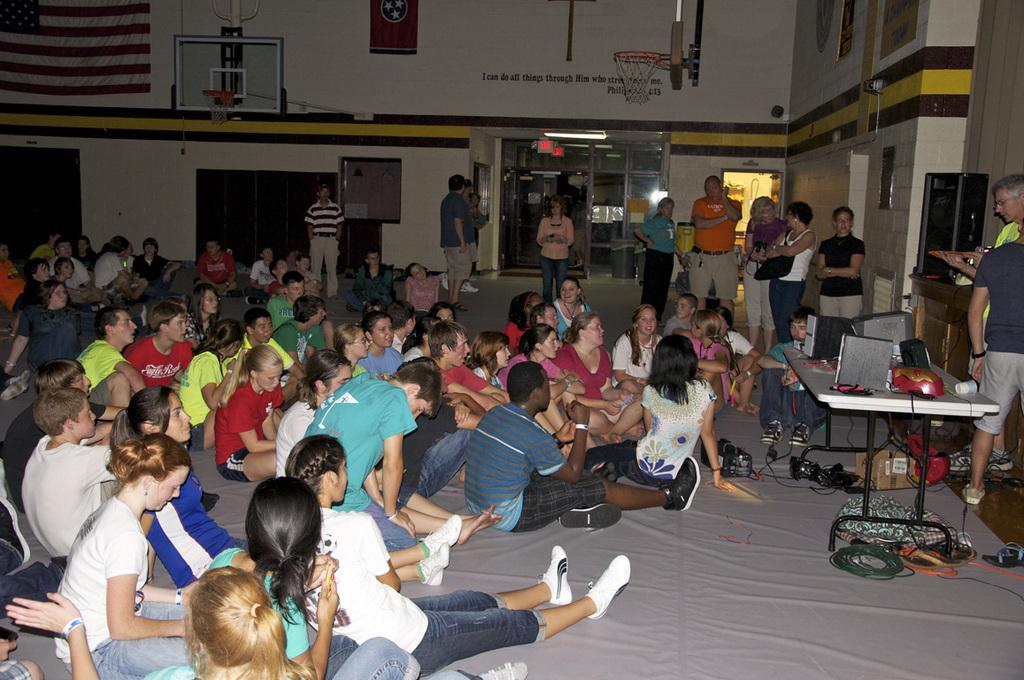What are the children doing in the image? The children are sitting on the floor in the image. What else can be seen in the image besides the children? There is a table and persons standing in the image. What is the location or setting of the image? There is a basketball court visible in the image. What type of fruit is growing in the garden in the image? There is no garden or fruit present in the image. How does the nerve system of the children affect their ability to play basketball in the image? There is no information about the children's nerve systems or their ability to play basketball in the image. 